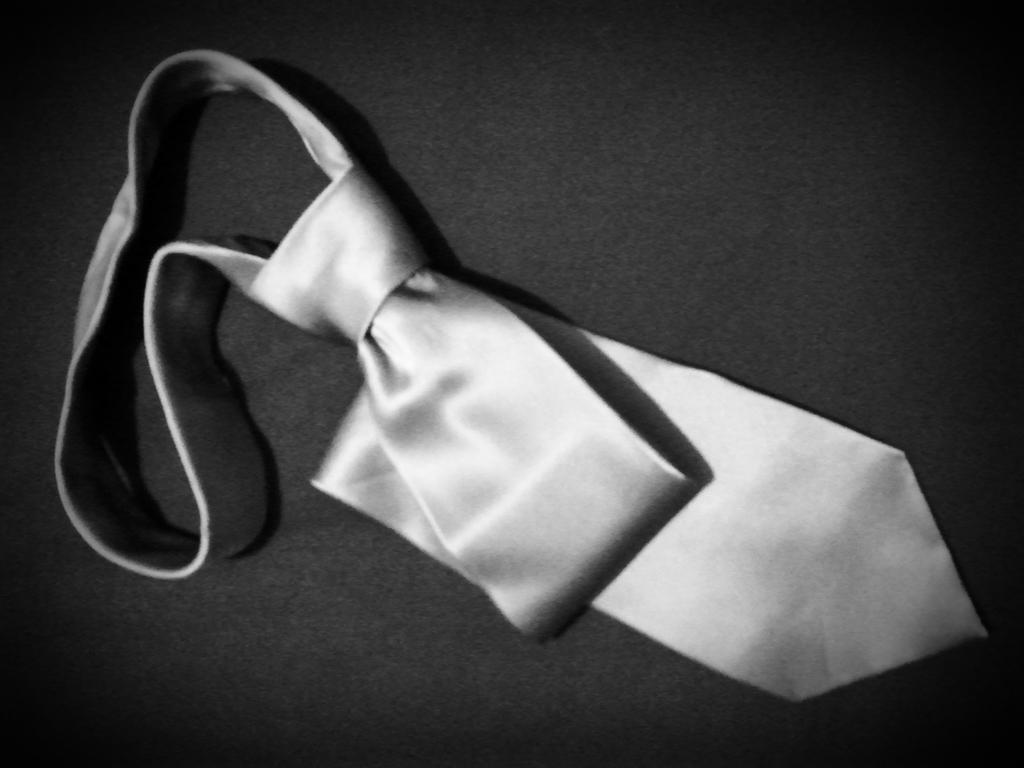What type of clothing accessory is present in the image? There is a tie in the image. On what surface is the tie placed? The tie is placed on a black surface. What is the color scheme of the image? The image is black and white. How many birds can be seen perched on the tie in the image? There are no birds present in the image. What type of rings are visible on the tie in the image? There are no rings present on the tie in the image. Where is the library located in the image? There is no library present in the image. 